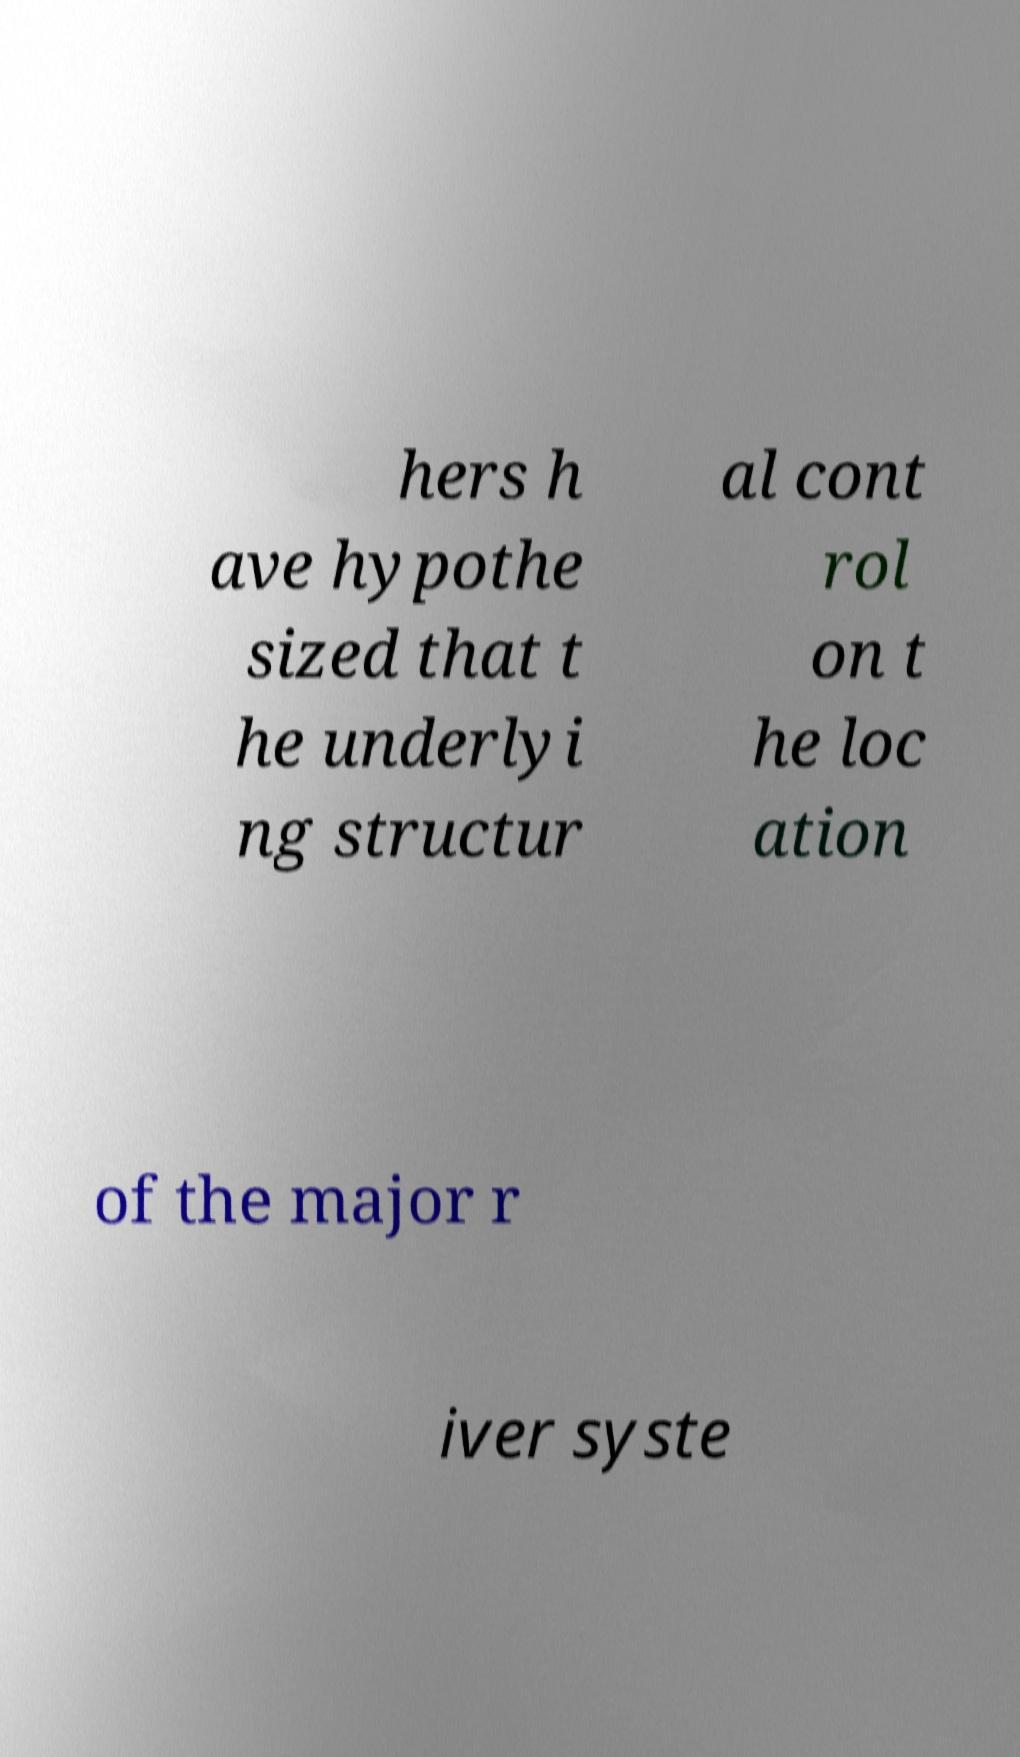Could you assist in decoding the text presented in this image and type it out clearly? hers h ave hypothe sized that t he underlyi ng structur al cont rol on t he loc ation of the major r iver syste 